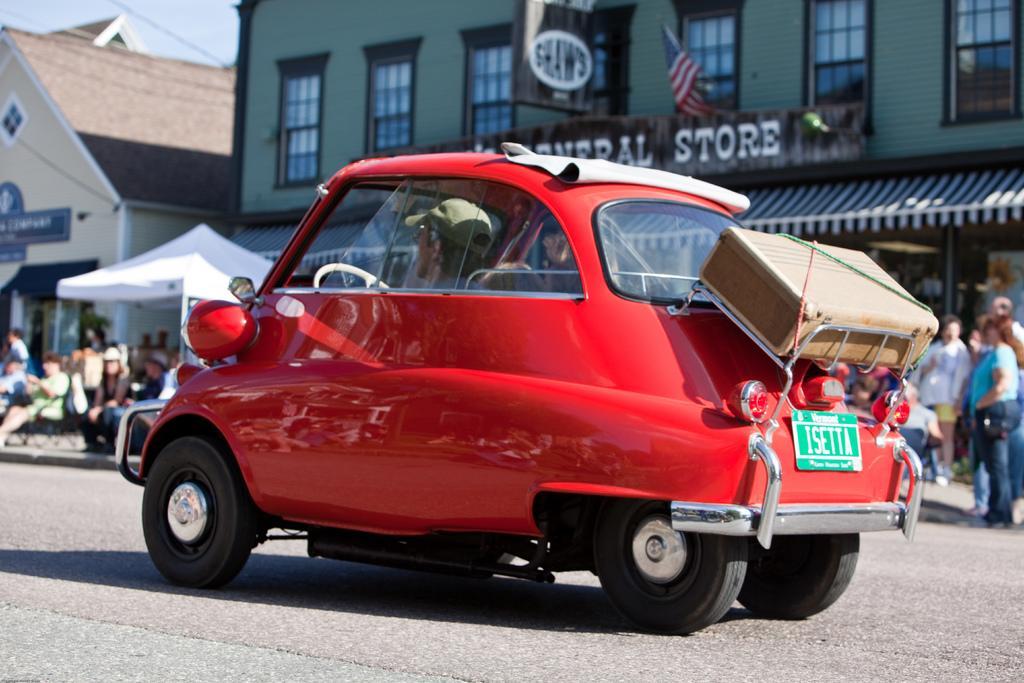In one or two sentences, can you explain what this image depicts? In this image we can see vehicles such as cars on the road. And we can see the buildings. And we can see the sky. And we can see the flags on the building. And we can see some text written on the building. And we can see a few people near the building. 